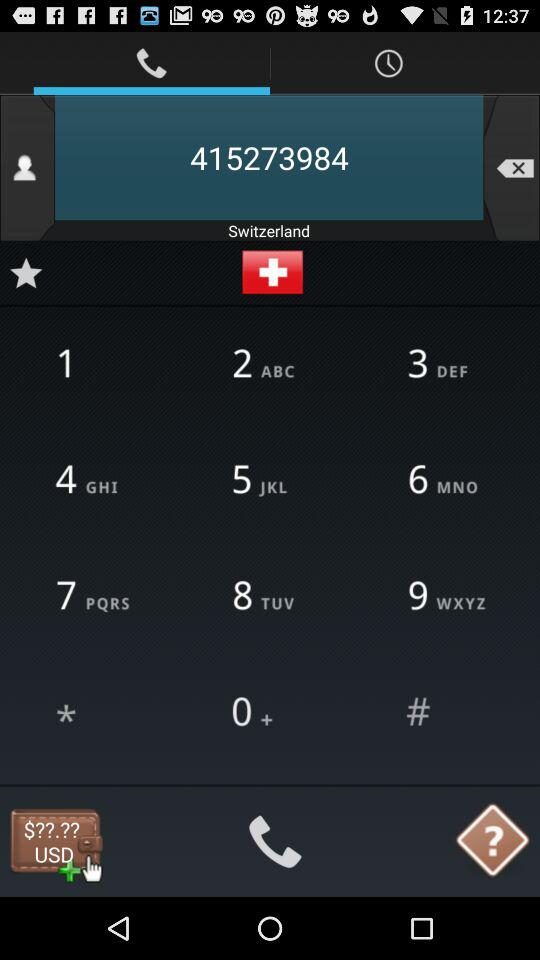What is the phone number? The phone number is 415273984. 